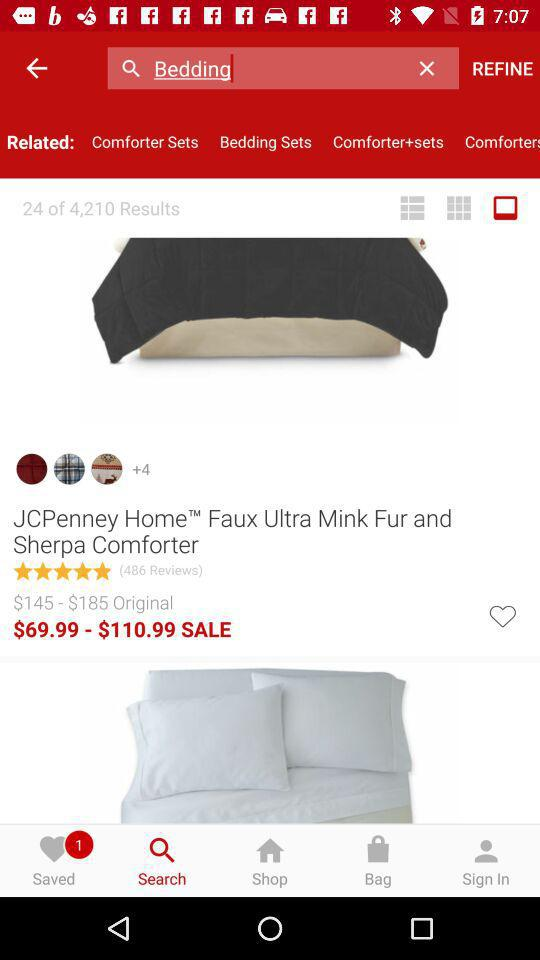Which tab is selected? The selected tab is "Search". 